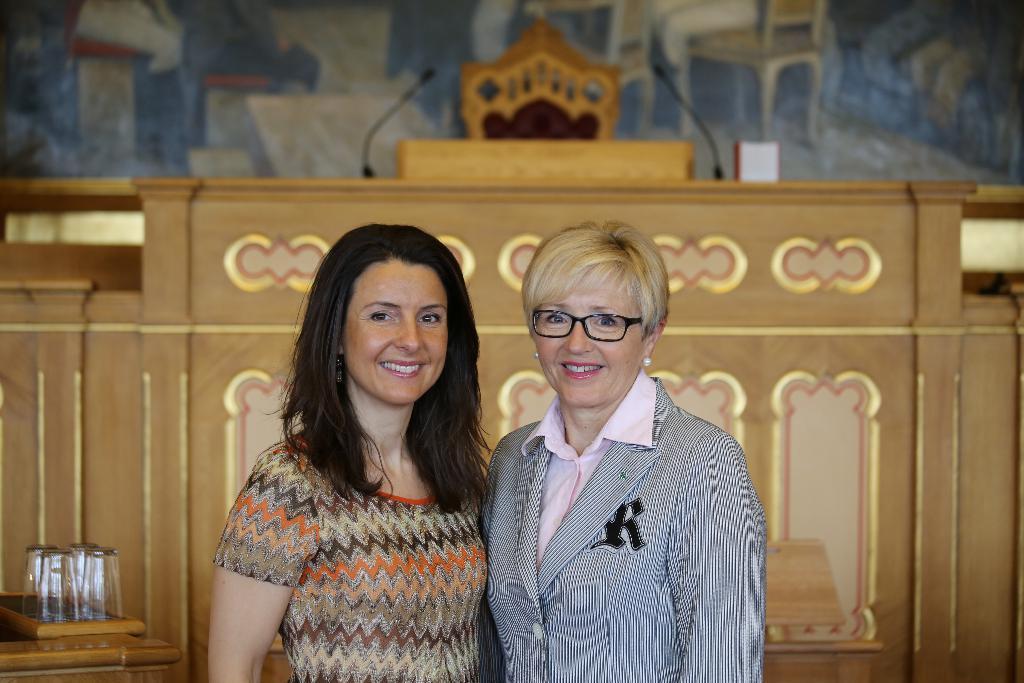Can you describe this image briefly? In the picture we can see two women are standing together, one woman is with loose hair and she is smiling and one woman is to short and a blazer and she are also smiling and behind them, we can see a wooden wall and on the top of it, we can see a desk with two microphones and a chair and behind it we can see a wall with some paintings of chairs on it and near to the wall we can see a table with some glasses on it. 